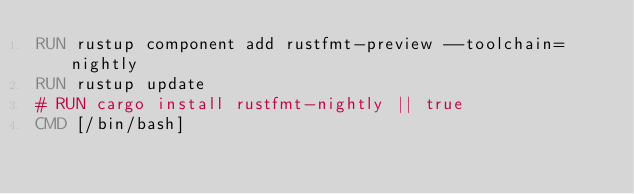<code> <loc_0><loc_0><loc_500><loc_500><_Dockerfile_>RUN rustup component add rustfmt-preview --toolchain=nightly
RUN rustup update
# RUN cargo install rustfmt-nightly || true
CMD [/bin/bash]
</code> 